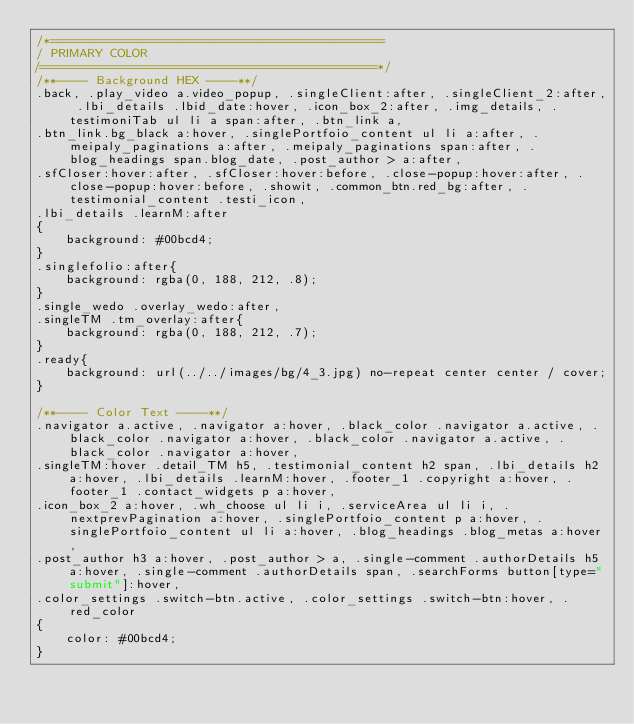Convert code to text. <code><loc_0><loc_0><loc_500><loc_500><_CSS_>/*=============================================
/ PRIMARY COLOR 
/=============================================*/
/**---- Background HEX ----**/
.back, .play_video a.video_popup, .singleClient:after, .singleClient_2:after, .lbi_details .lbid_date:hover, .icon_box_2:after, .img_details, .testimoniTab ul li a span:after, .btn_link a,
.btn_link.bg_black a:hover, .singlePortfoio_content ul li a:after, .meipaly_paginations a:after, .meipaly_paginations span:after, .blog_headings span.blog_date, .post_author > a:after,
.sfCloser:hover:after, .sfCloser:hover:before, .close-popup:hover:after, .close-popup:hover:before, .showit, .common_btn.red_bg:after, .testimonial_content .testi_icon, 
.lbi_details .learnM:after
{
    background: #00bcd4;
}
.singlefolio:after{
    background: rgba(0, 188, 212, .8);
}
.single_wedo .overlay_wedo:after,
.singleTM .tm_overlay:after{
    background: rgba(0, 188, 212, .7);
}
.ready{
    background: url(../../images/bg/4_3.jpg) no-repeat center center / cover;
}

/**---- Color Text ----**/
.navigator a.active, .navigator a:hover, .black_color .navigator a.active, .black_color .navigator a:hover, .black_color .navigator a.active, .black_color .navigator a:hover,
.singleTM:hover .detail_TM h5, .testimonial_content h2 span, .lbi_details h2 a:hover, .lbi_details .learnM:hover, .footer_1 .copyright a:hover, .footer_1 .contact_widgets p a:hover,
.icon_box_2 a:hover, .wh_choose ul li i, .serviceArea ul li i, .nextprevPagination a:hover, .singlePortfoio_content p a:hover, .singlePortfoio_content ul li a:hover, .blog_headings .blog_metas a:hover,
.post_author h3 a:hover, .post_author > a, .single-comment .authorDetails h5 a:hover, .single-comment .authorDetails span, .searchForms button[type="submit"]:hover,
.color_settings .switch-btn.active, .color_settings .switch-btn:hover, .red_color
{
    color: #00bcd4;
}</code> 